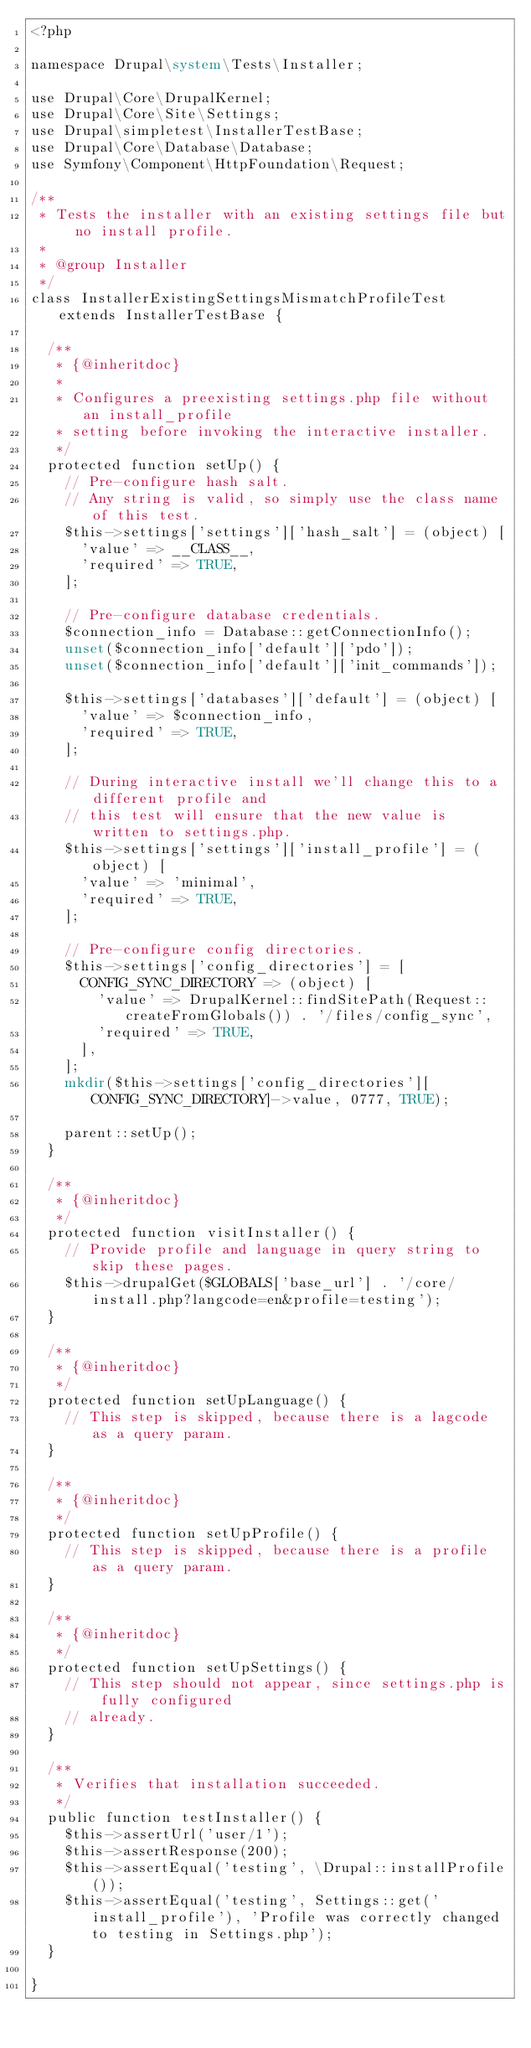<code> <loc_0><loc_0><loc_500><loc_500><_PHP_><?php

namespace Drupal\system\Tests\Installer;

use Drupal\Core\DrupalKernel;
use Drupal\Core\Site\Settings;
use Drupal\simpletest\InstallerTestBase;
use Drupal\Core\Database\Database;
use Symfony\Component\HttpFoundation\Request;

/**
 * Tests the installer with an existing settings file but no install profile.
 *
 * @group Installer
 */
class InstallerExistingSettingsMismatchProfileTest extends InstallerTestBase {

  /**
   * {@inheritdoc}
   *
   * Configures a preexisting settings.php file without an install_profile
   * setting before invoking the interactive installer.
   */
  protected function setUp() {
    // Pre-configure hash salt.
    // Any string is valid, so simply use the class name of this test.
    $this->settings['settings']['hash_salt'] = (object) [
      'value' => __CLASS__,
      'required' => TRUE,
    ];

    // Pre-configure database credentials.
    $connection_info = Database::getConnectionInfo();
    unset($connection_info['default']['pdo']);
    unset($connection_info['default']['init_commands']);

    $this->settings['databases']['default'] = (object) [
      'value' => $connection_info,
      'required' => TRUE,
    ];

    // During interactive install we'll change this to a different profile and
    // this test will ensure that the new value is written to settings.php.
    $this->settings['settings']['install_profile'] = (object) [
      'value' => 'minimal',
      'required' => TRUE,
    ];

    // Pre-configure config directories.
    $this->settings['config_directories'] = [
      CONFIG_SYNC_DIRECTORY => (object) [
        'value' => DrupalKernel::findSitePath(Request::createFromGlobals()) . '/files/config_sync',
        'required' => TRUE,
      ],
    ];
    mkdir($this->settings['config_directories'][CONFIG_SYNC_DIRECTORY]->value, 0777, TRUE);

    parent::setUp();
  }

  /**
   * {@inheritdoc}
   */
  protected function visitInstaller() {
    // Provide profile and language in query string to skip these pages.
    $this->drupalGet($GLOBALS['base_url'] . '/core/install.php?langcode=en&profile=testing');
  }

  /**
   * {@inheritdoc}
   */
  protected function setUpLanguage() {
    // This step is skipped, because there is a lagcode as a query param.
  }

  /**
   * {@inheritdoc}
   */
  protected function setUpProfile() {
    // This step is skipped, because there is a profile as a query param.
  }

  /**
   * {@inheritdoc}
   */
  protected function setUpSettings() {
    // This step should not appear, since settings.php is fully configured
    // already.
  }

  /**
   * Verifies that installation succeeded.
   */
  public function testInstaller() {
    $this->assertUrl('user/1');
    $this->assertResponse(200);
    $this->assertEqual('testing', \Drupal::installProfile());
    $this->assertEqual('testing', Settings::get('install_profile'), 'Profile was correctly changed to testing in Settings.php');
  }

}
</code> 